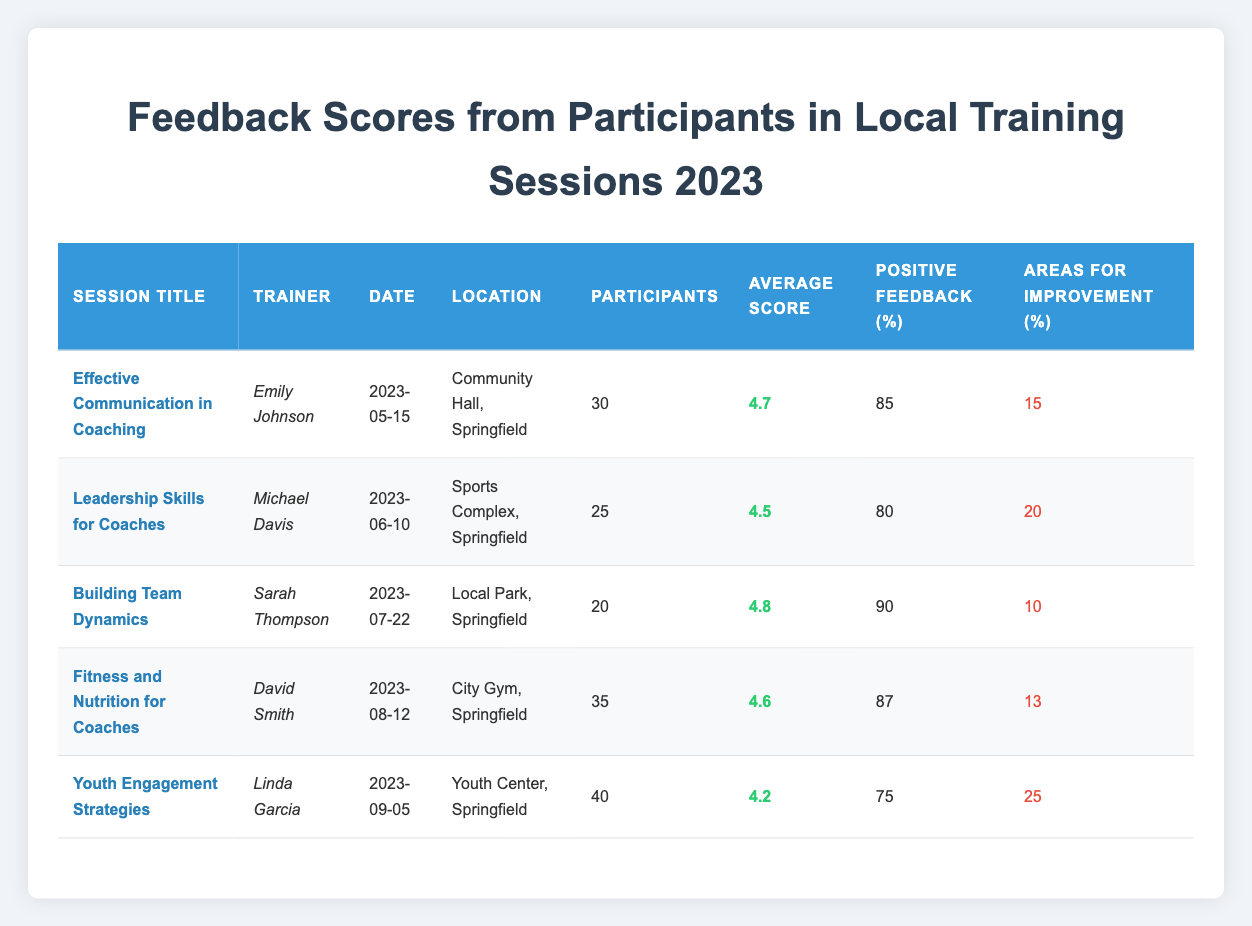What is the highest average score among the training sessions? The average scores for each session are: 4.7, 4.5, 4.8, 4.6, and 4.2. The highest score is 4.8 from the session "Building Team Dynamics."
Answer: 4.8 Which session had the most participants? The number of participants in each session is: 30, 25, 20, 35, and 40. The session with the most participants is "Youth Engagement Strategies" with 40 participants.
Answer: 40 What percentage of positive feedback was received for the session "Fitness and Nutrition for Coaches"? The percentage of positive feedback for this session is explicitly listed as 87%.
Answer: 87% How many sessions had a positive feedback percentage of 80% or lower? The sessions with 80% or lower positive feedback are: "Leadership Skills for Coaches" (80%) and "Youth Engagement Strategies" (75%). There are 2 such sessions.
Answer: 2 What is the average score of the sessions conducted by trainers with the first name starting with a vowel? The trainers with first names starting with vowels are Emily (4.7), and David (4.6). The average score is (4.7 + 4.6) / 2 = 4.65.
Answer: 4.65 Which session had the highest area for improvement percentage, and what was that percentage? The area for improvement percentages for each session are: 15%, 20%, 10%, 13%, and 25%. The highest is 25% from the session "Youth Engagement Strategies."
Answer: 25% Was the average score for "Effective Communication in Coaching" greater than 4.5? The average score for "Effective Communication in Coaching" is 4.7, which is indeed greater than 4.5.
Answer: Yes What is the total number of participants across all sessions? The total number of participants is 30 + 25 + 20 + 35 + 40 = 150.
Answer: 150 How many sessions had an average score higher than 4.5? The sessions with average scores higher than 4.5 are: "Effective Communication in Coaching" (4.7), "Building Team Dynamics" (4.8), and "Fitness and Nutrition for Coaches" (4.6). This makes for 3 such sessions.
Answer: 3 Calculate the difference in average scores between the highest and lowest scoring sessions. The highest average score is 4.8 (from "Building Team Dynamics") and the lowest is 4.2 (from "Youth Engagement Strategies"). The difference is 4.8 - 4.2 = 0.6.
Answer: 0.6 